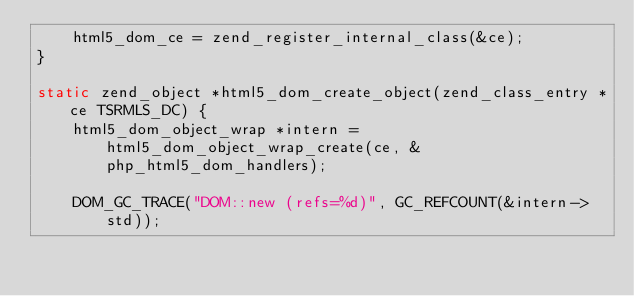Convert code to text. <code><loc_0><loc_0><loc_500><loc_500><_C_>	html5_dom_ce = zend_register_internal_class(&ce);
}

static zend_object *html5_dom_create_object(zend_class_entry *ce TSRMLS_DC) {
	html5_dom_object_wrap *intern = html5_dom_object_wrap_create(ce, &php_html5_dom_handlers);
	
	DOM_GC_TRACE("DOM::new (refs=%d)", GC_REFCOUNT(&intern->std));
	</code> 